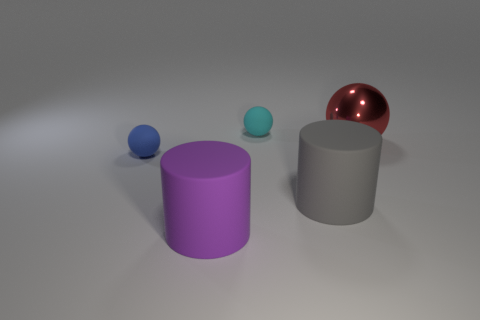Is the blue matte object the same shape as the purple matte thing?
Ensure brevity in your answer.  No. Is there any other thing that has the same size as the cyan object?
Offer a terse response. Yes. How many blue matte things are behind the big red object?
Provide a succinct answer. 0. Do the matte object behind the metallic thing and the gray thing have the same size?
Ensure brevity in your answer.  No. What color is the other tiny rubber thing that is the same shape as the blue thing?
Your response must be concise. Cyan. Is there anything else that has the same shape as the red metal thing?
Ensure brevity in your answer.  Yes. What shape is the small rubber object behind the metal thing?
Make the answer very short. Sphere. What number of other things are the same shape as the big metal object?
Your response must be concise. 2. Is the color of the matte ball in front of the metallic object the same as the small rubber object that is right of the tiny blue sphere?
Keep it short and to the point. No. How many things are either big purple matte cylinders or brown cylinders?
Ensure brevity in your answer.  1. 